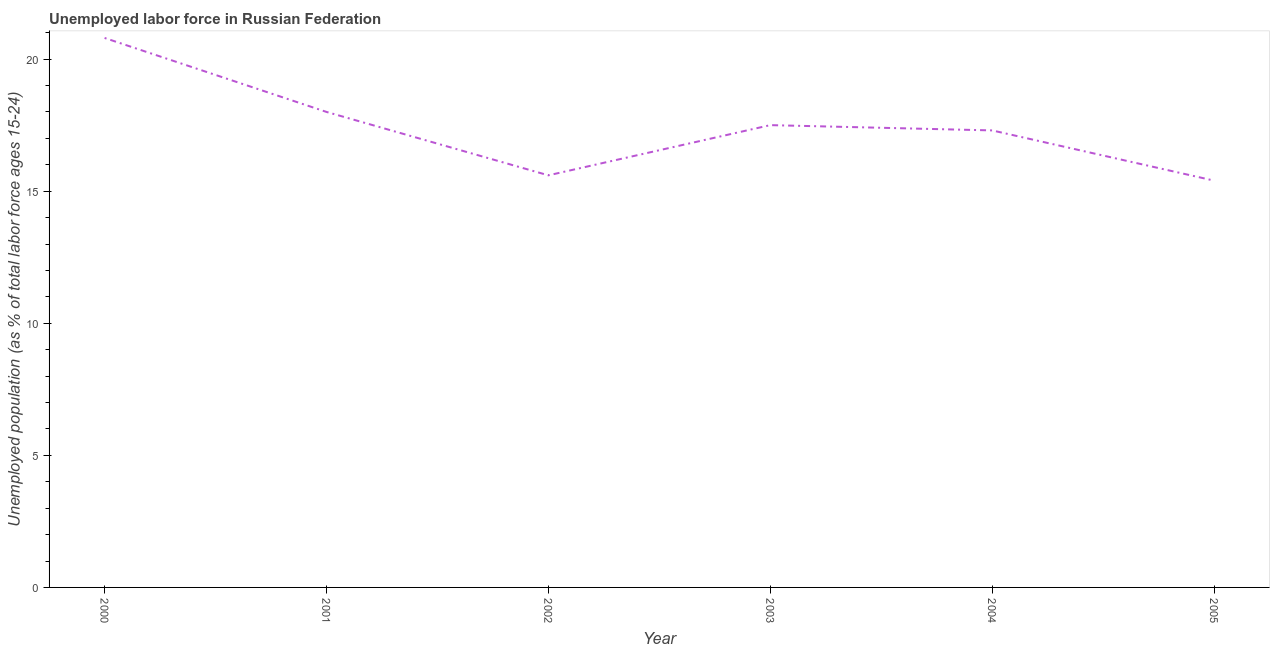Across all years, what is the maximum total unemployed youth population?
Ensure brevity in your answer.  20.8. Across all years, what is the minimum total unemployed youth population?
Make the answer very short. 15.4. In which year was the total unemployed youth population minimum?
Make the answer very short. 2005. What is the sum of the total unemployed youth population?
Ensure brevity in your answer.  104.6. What is the average total unemployed youth population per year?
Keep it short and to the point. 17.43. What is the median total unemployed youth population?
Keep it short and to the point. 17.4. What is the ratio of the total unemployed youth population in 2004 to that in 2005?
Your answer should be compact. 1.12. Is the difference between the total unemployed youth population in 2001 and 2004 greater than the difference between any two years?
Offer a very short reply. No. What is the difference between the highest and the second highest total unemployed youth population?
Your answer should be very brief. 2.8. Is the sum of the total unemployed youth population in 2001 and 2004 greater than the maximum total unemployed youth population across all years?
Make the answer very short. Yes. What is the difference between the highest and the lowest total unemployed youth population?
Offer a terse response. 5.4. Does the total unemployed youth population monotonically increase over the years?
Your answer should be very brief. No. How many lines are there?
Make the answer very short. 1. What is the difference between two consecutive major ticks on the Y-axis?
Give a very brief answer. 5. Does the graph contain grids?
Offer a very short reply. No. What is the title of the graph?
Offer a very short reply. Unemployed labor force in Russian Federation. What is the label or title of the X-axis?
Your response must be concise. Year. What is the label or title of the Y-axis?
Your response must be concise. Unemployed population (as % of total labor force ages 15-24). What is the Unemployed population (as % of total labor force ages 15-24) of 2000?
Your answer should be compact. 20.8. What is the Unemployed population (as % of total labor force ages 15-24) of 2002?
Provide a succinct answer. 15.6. What is the Unemployed population (as % of total labor force ages 15-24) of 2004?
Offer a terse response. 17.3. What is the Unemployed population (as % of total labor force ages 15-24) of 2005?
Your answer should be compact. 15.4. What is the difference between the Unemployed population (as % of total labor force ages 15-24) in 2000 and 2001?
Make the answer very short. 2.8. What is the difference between the Unemployed population (as % of total labor force ages 15-24) in 2000 and 2002?
Offer a terse response. 5.2. What is the difference between the Unemployed population (as % of total labor force ages 15-24) in 2000 and 2005?
Provide a succinct answer. 5.4. What is the difference between the Unemployed population (as % of total labor force ages 15-24) in 2001 and 2002?
Ensure brevity in your answer.  2.4. What is the difference between the Unemployed population (as % of total labor force ages 15-24) in 2001 and 2003?
Your answer should be very brief. 0.5. What is the difference between the Unemployed population (as % of total labor force ages 15-24) in 2001 and 2004?
Keep it short and to the point. 0.7. What is the difference between the Unemployed population (as % of total labor force ages 15-24) in 2001 and 2005?
Offer a terse response. 2.6. What is the difference between the Unemployed population (as % of total labor force ages 15-24) in 2002 and 2003?
Give a very brief answer. -1.9. What is the difference between the Unemployed population (as % of total labor force ages 15-24) in 2002 and 2004?
Your answer should be compact. -1.7. What is the difference between the Unemployed population (as % of total labor force ages 15-24) in 2002 and 2005?
Your answer should be compact. 0.2. What is the difference between the Unemployed population (as % of total labor force ages 15-24) in 2003 and 2004?
Offer a very short reply. 0.2. What is the difference between the Unemployed population (as % of total labor force ages 15-24) in 2003 and 2005?
Ensure brevity in your answer.  2.1. What is the difference between the Unemployed population (as % of total labor force ages 15-24) in 2004 and 2005?
Keep it short and to the point. 1.9. What is the ratio of the Unemployed population (as % of total labor force ages 15-24) in 2000 to that in 2001?
Offer a terse response. 1.16. What is the ratio of the Unemployed population (as % of total labor force ages 15-24) in 2000 to that in 2002?
Provide a short and direct response. 1.33. What is the ratio of the Unemployed population (as % of total labor force ages 15-24) in 2000 to that in 2003?
Offer a terse response. 1.19. What is the ratio of the Unemployed population (as % of total labor force ages 15-24) in 2000 to that in 2004?
Make the answer very short. 1.2. What is the ratio of the Unemployed population (as % of total labor force ages 15-24) in 2000 to that in 2005?
Ensure brevity in your answer.  1.35. What is the ratio of the Unemployed population (as % of total labor force ages 15-24) in 2001 to that in 2002?
Ensure brevity in your answer.  1.15. What is the ratio of the Unemployed population (as % of total labor force ages 15-24) in 2001 to that in 2003?
Give a very brief answer. 1.03. What is the ratio of the Unemployed population (as % of total labor force ages 15-24) in 2001 to that in 2005?
Make the answer very short. 1.17. What is the ratio of the Unemployed population (as % of total labor force ages 15-24) in 2002 to that in 2003?
Give a very brief answer. 0.89. What is the ratio of the Unemployed population (as % of total labor force ages 15-24) in 2002 to that in 2004?
Keep it short and to the point. 0.9. What is the ratio of the Unemployed population (as % of total labor force ages 15-24) in 2002 to that in 2005?
Offer a terse response. 1.01. What is the ratio of the Unemployed population (as % of total labor force ages 15-24) in 2003 to that in 2004?
Keep it short and to the point. 1.01. What is the ratio of the Unemployed population (as % of total labor force ages 15-24) in 2003 to that in 2005?
Ensure brevity in your answer.  1.14. What is the ratio of the Unemployed population (as % of total labor force ages 15-24) in 2004 to that in 2005?
Provide a short and direct response. 1.12. 